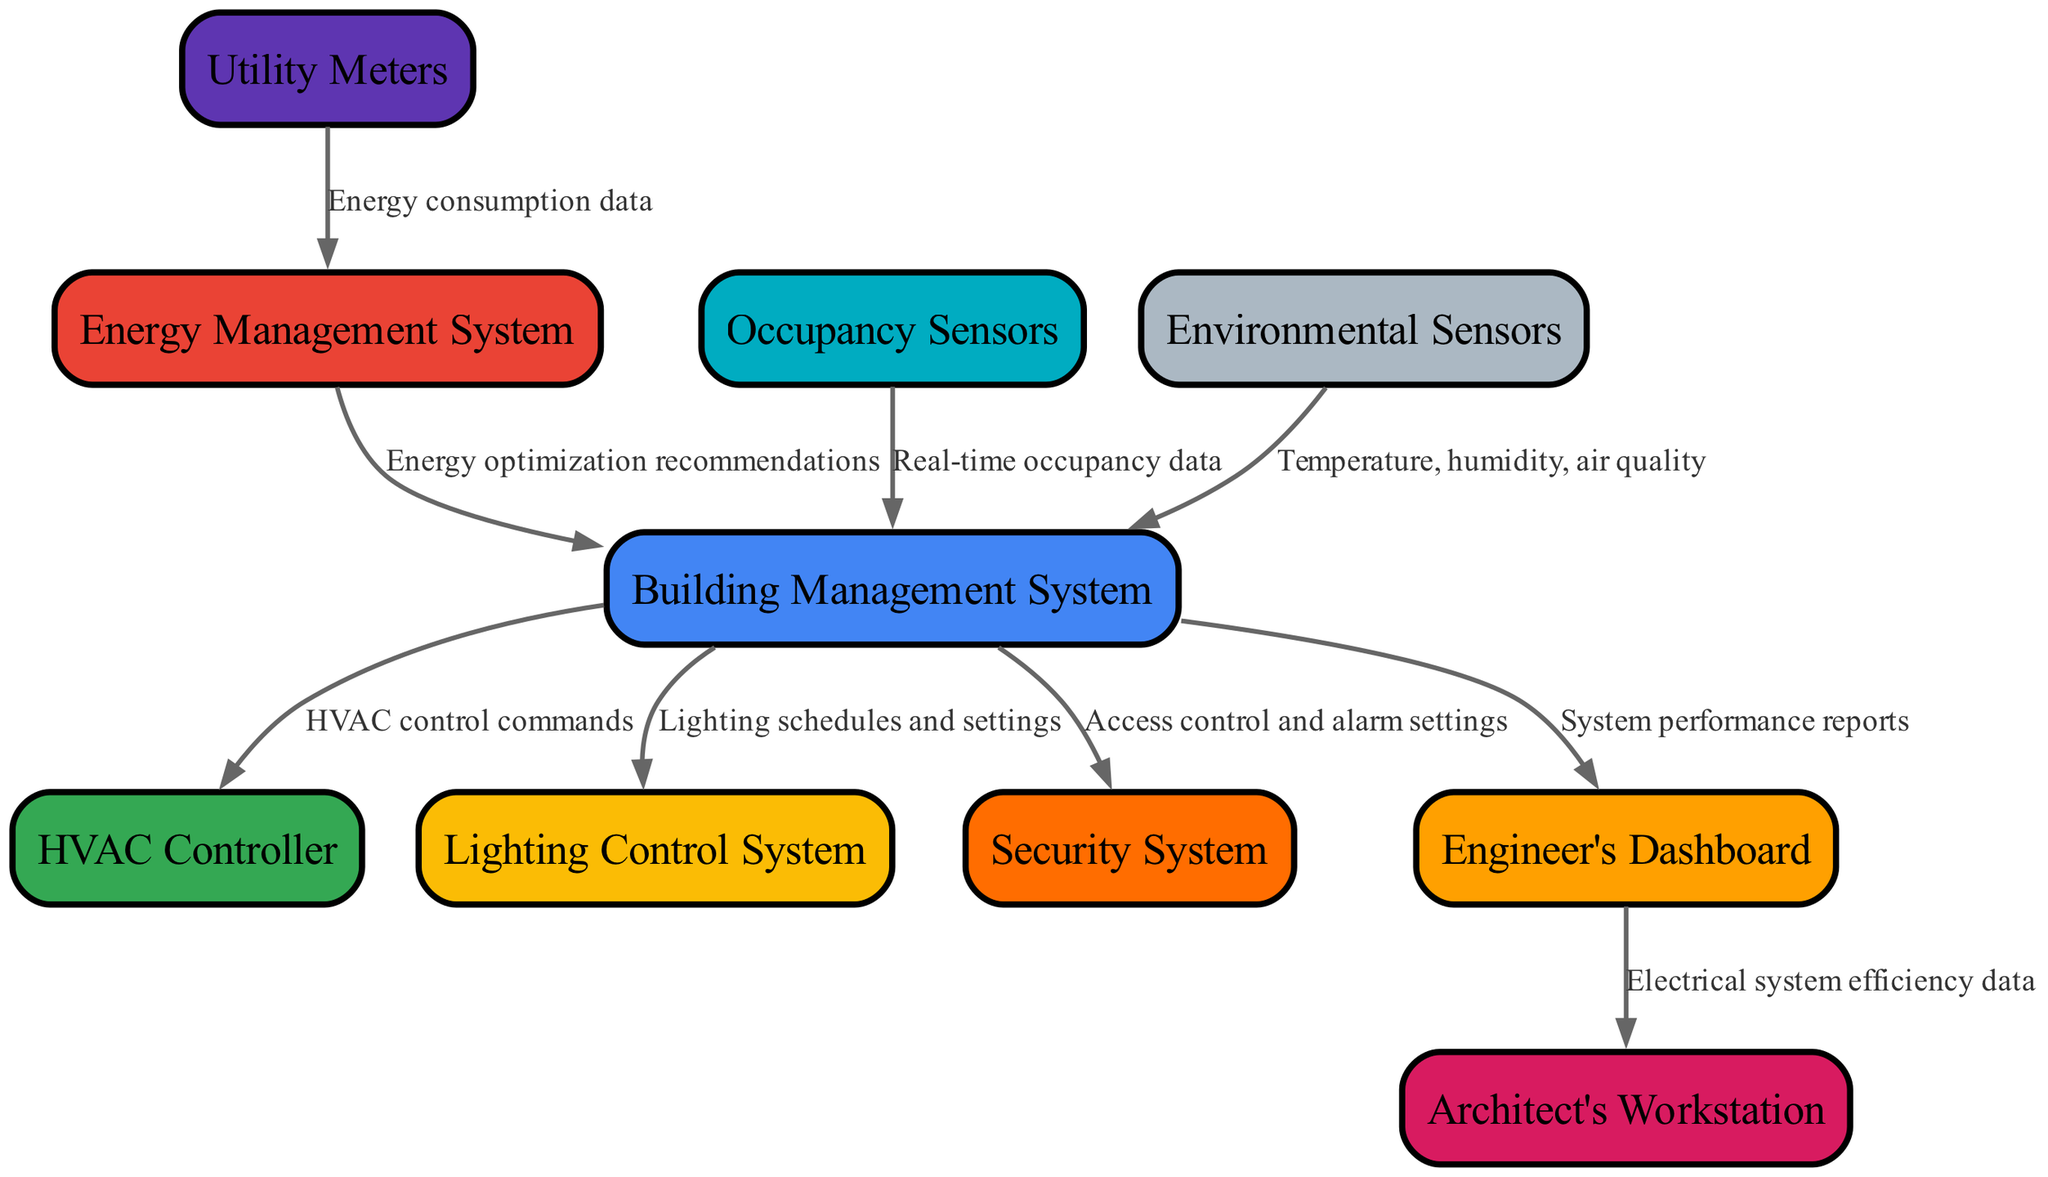What are the main systems involved in the Building Management System? The diagram shows that the Building Management System interacts with several main systems: HVAC Controller, Lighting Control System, Energy Management System, and Security System. Each of these systems receives input from the Building Management System to perform their respective functions.
Answer: HVAC Controller, Lighting Control System, Energy Management System, Security System How many data flows are outgoing from the Building Management System? Upon examining the diagram, we see that there are four outgoing data flows from the Building Management System: to the HVAC Controller, Lighting Control System, Security System, and Engineer's Dashboard.
Answer: 4 What data do the Occupancy Sensors send? The diagram indicates that the Occupancy Sensors send real-time occupancy data to the Building Management System. This data is crucial for making decisions regarding building automation, especially for energy efficiency and comfort.
Answer: Real-time occupancy data Which system receives energy optimization recommendations? The data flow from the Energy Management System to the Building Management System shows that this is where the energy optimization recommendations are directed. The recommendations aid the overall efficiency of the building's systems.
Answer: Building Management System What is the role of the Engineer's Dashboard in relation to the Architect's Workstation? The Engineer's Dashboard is designed to provide electrical system efficiency data to the Architect's Workstation. This enables architects to make informed decisions based on the efficiency metrics related to the electrical systems they are designing.
Answer: Electrical system efficiency data How many types of sensors are listed in the diagram? The diagram specifies two types of sensors: Occupancy Sensors and Environmental Sensors. Both of these sensors provide critical data to the Building Management System to ensure optimal building function.
Answer: 2 What kind of data do Environmental Sensors provide? According to the diagram, Environmental Sensors send temperature, humidity, and air quality data to the Building Management System. This information is essential for maintaining a comfortable and safe environment in the building.
Answer: Temperature, humidity, air quality Which system is responsible for alarm settings based on data from the Building Management System? The diagram shows that the Security System receives access control and alarm settings from the Building Management System, indicating that the Security System acts on critical inputs from the overarching management system.
Answer: Security System 